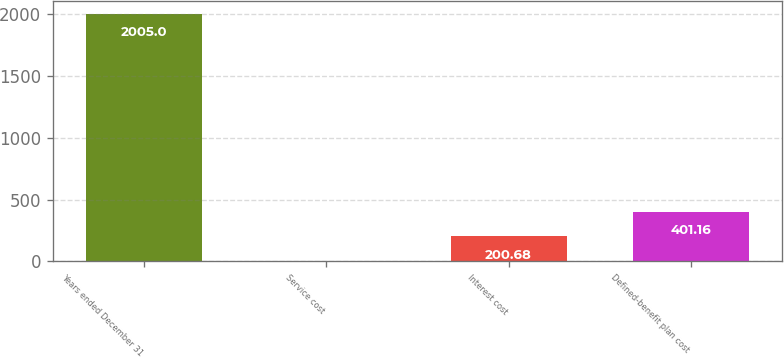<chart> <loc_0><loc_0><loc_500><loc_500><bar_chart><fcel>Years ended December 31<fcel>Service cost<fcel>Interest cost<fcel>Defined-benefit plan cost<nl><fcel>2005<fcel>0.2<fcel>200.68<fcel>401.16<nl></chart> 